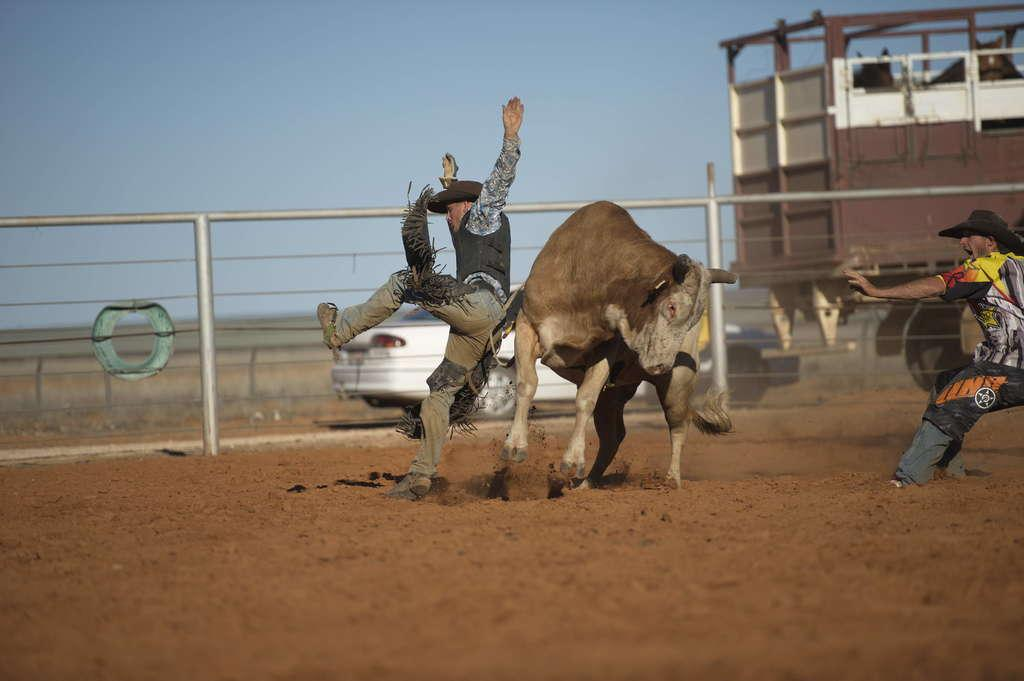What type of animal is present in the image? There is an animal in the image. Can you describe the position of the animal in relation to the two persons? The animal is between two persons. What else can be seen in the image besides the animal and the persons? There are vehicles beside a fence in the image. What is visible in the background of the image? The sky is visible in the background of the image. How many mice are hiding under the sweater in the image? There are no mice or sweater present in the image. What type of pig can be seen interacting with the animal in the image? There is no pig present in the image; only the animal, two persons, vehicles, a fence, and the sky are visible. 